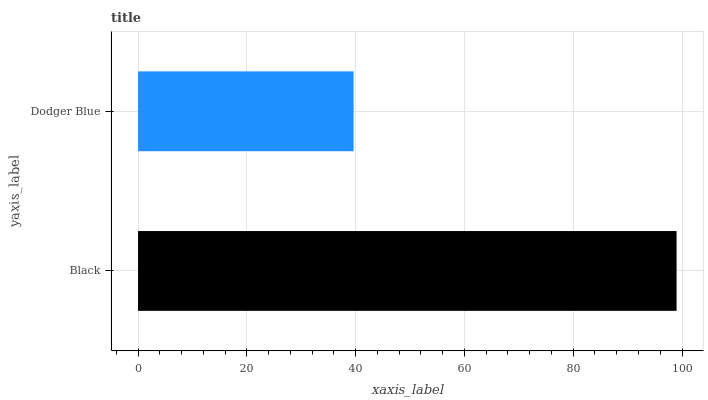Is Dodger Blue the minimum?
Answer yes or no. Yes. Is Black the maximum?
Answer yes or no. Yes. Is Dodger Blue the maximum?
Answer yes or no. No. Is Black greater than Dodger Blue?
Answer yes or no. Yes. Is Dodger Blue less than Black?
Answer yes or no. Yes. Is Dodger Blue greater than Black?
Answer yes or no. No. Is Black less than Dodger Blue?
Answer yes or no. No. Is Black the high median?
Answer yes or no. Yes. Is Dodger Blue the low median?
Answer yes or no. Yes. Is Dodger Blue the high median?
Answer yes or no. No. Is Black the low median?
Answer yes or no. No. 